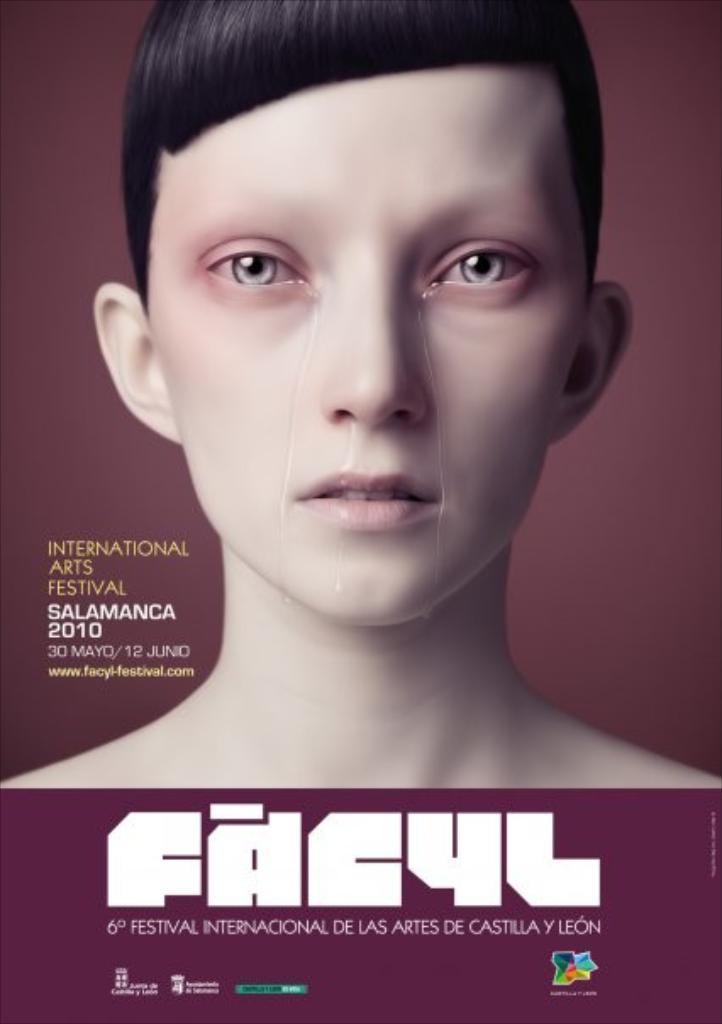Describe this image in one or two sentences. This image consists of a poster. On this poster, I can see some text and an image of a person. 